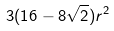Convert formula to latex. <formula><loc_0><loc_0><loc_500><loc_500>3 ( 1 6 - 8 \sqrt { 2 } ) r ^ { 2 }</formula> 